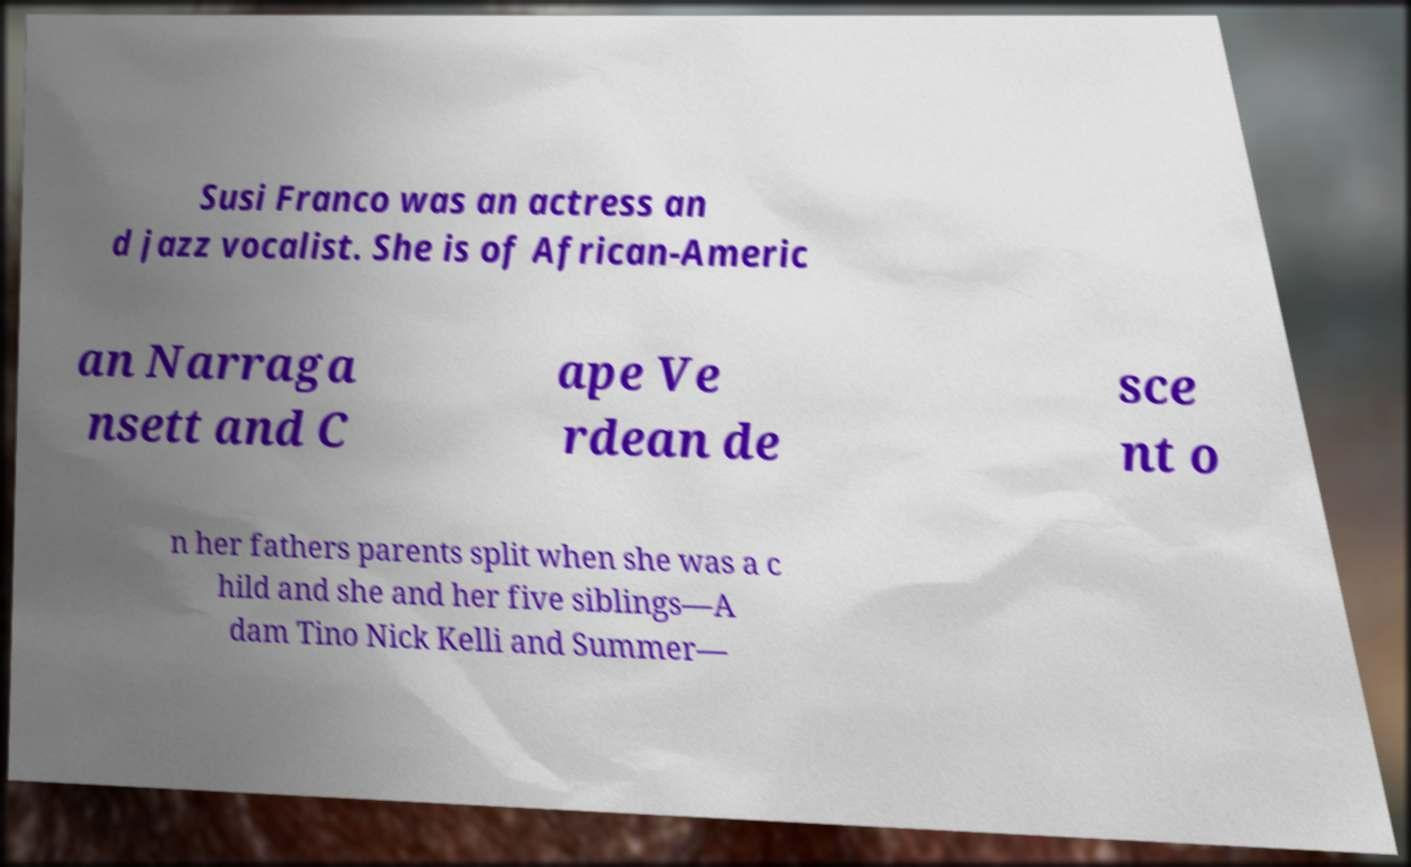Please identify and transcribe the text found in this image. Susi Franco was an actress an d jazz vocalist. She is of African-Americ an Narraga nsett and C ape Ve rdean de sce nt o n her fathers parents split when she was a c hild and she and her five siblings—A dam Tino Nick Kelli and Summer— 